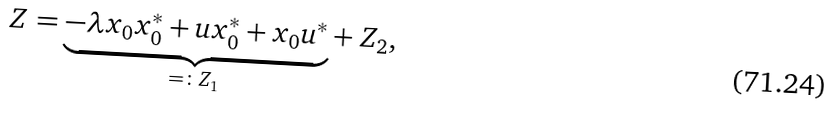<formula> <loc_0><loc_0><loc_500><loc_500>Z = \underset { = \colon Z _ { 1 } } { \underbrace { - \lambda x _ { 0 } x ^ { * } _ { 0 } + u x ^ { * } _ { 0 } + x _ { 0 } u ^ { * } } } + Z _ { 2 } ,</formula> 